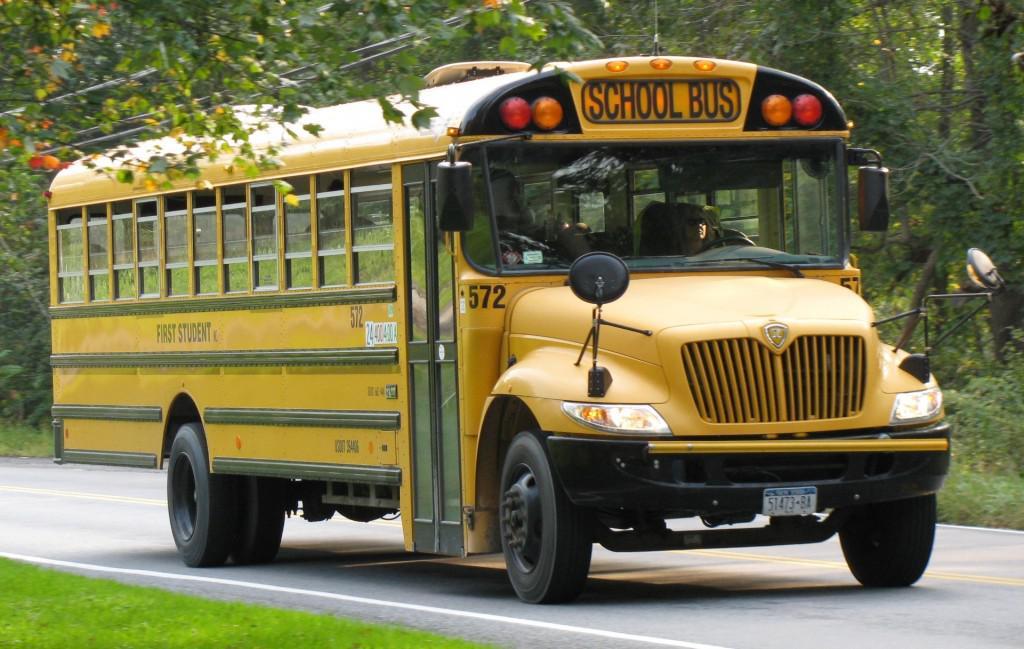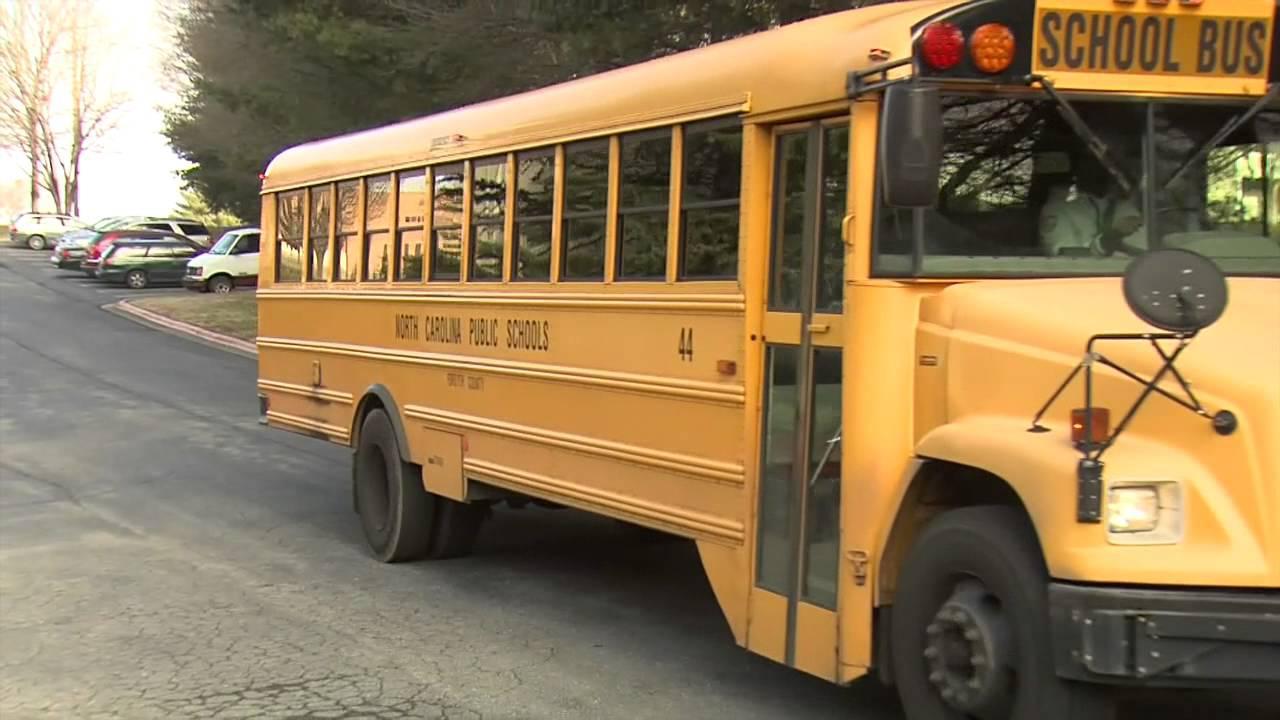The first image is the image on the left, the second image is the image on the right. Examine the images to the left and right. Is the description "There are two school buses in total." accurate? Answer yes or no. Yes. The first image is the image on the left, the second image is the image on the right. For the images shown, is this caption "Exactly two buses are visible." true? Answer yes or no. Yes. 